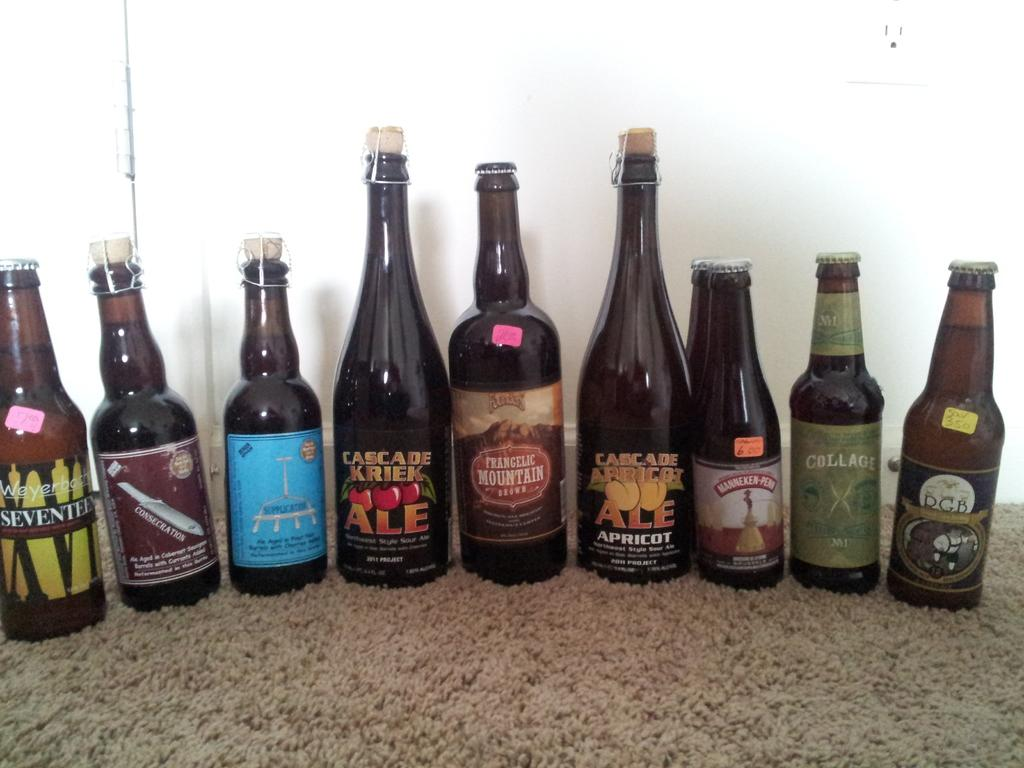Provide a one-sentence caption for the provided image. The bottle with the cherries on it is called Cascade Creek Ale. 